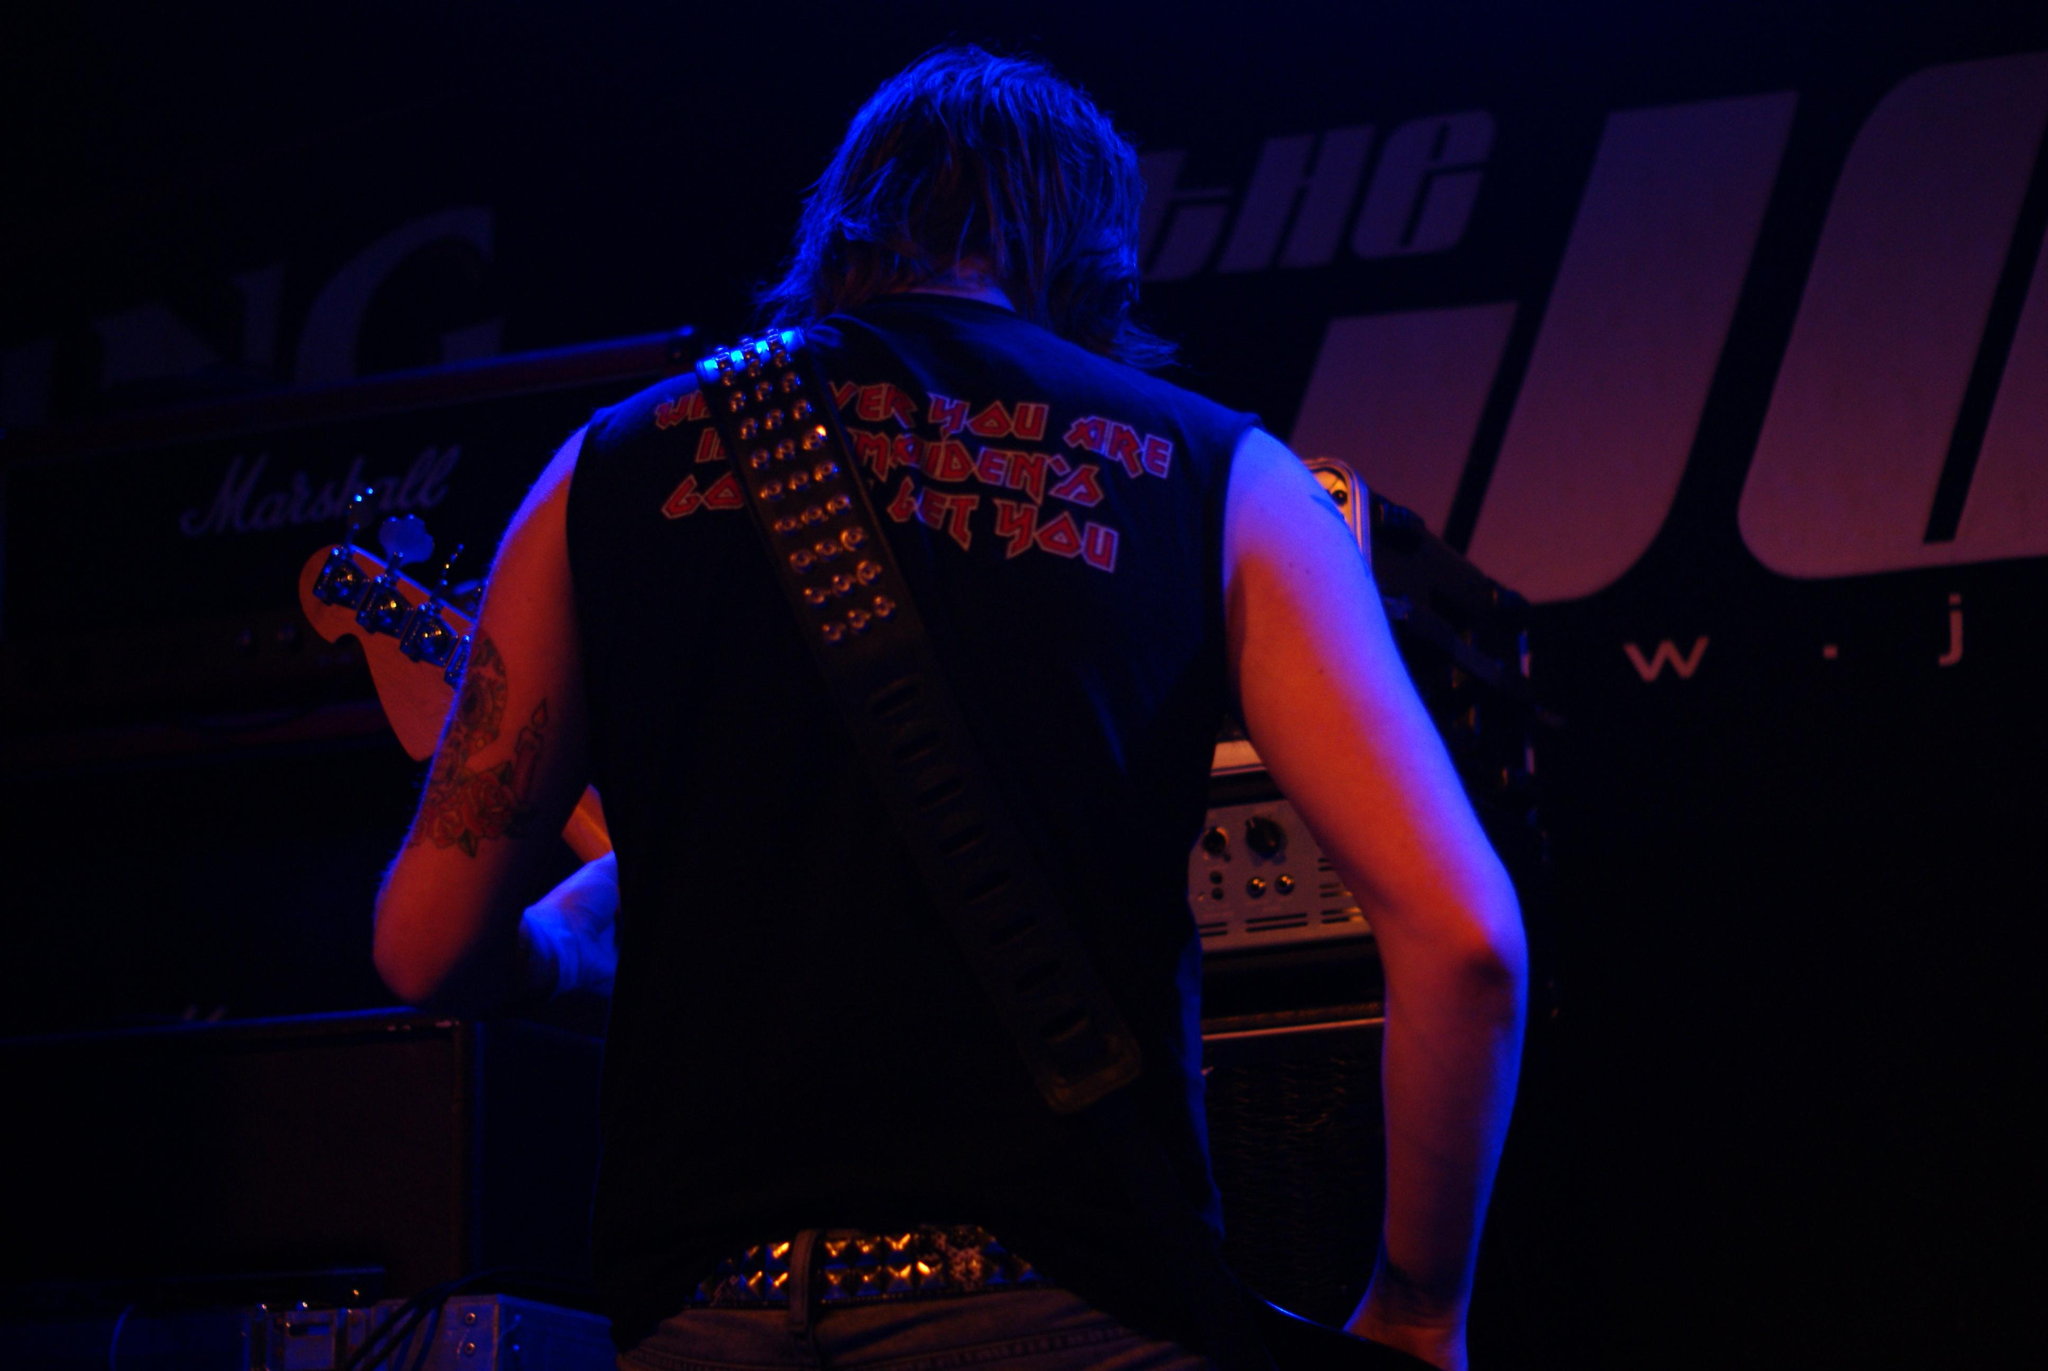What is the main subject of the image? There is a man standing in the image. What is the man wearing in the image? The man is wearing a guitar in the image. What else can be seen in the image besides the man? There are devices on a table in the image. What type of pencil can be seen on the table in the image? There is no pencil present on the table in the image. Is there a receipt visible on the table in the image? There is no receipt visible on the table in the image. 